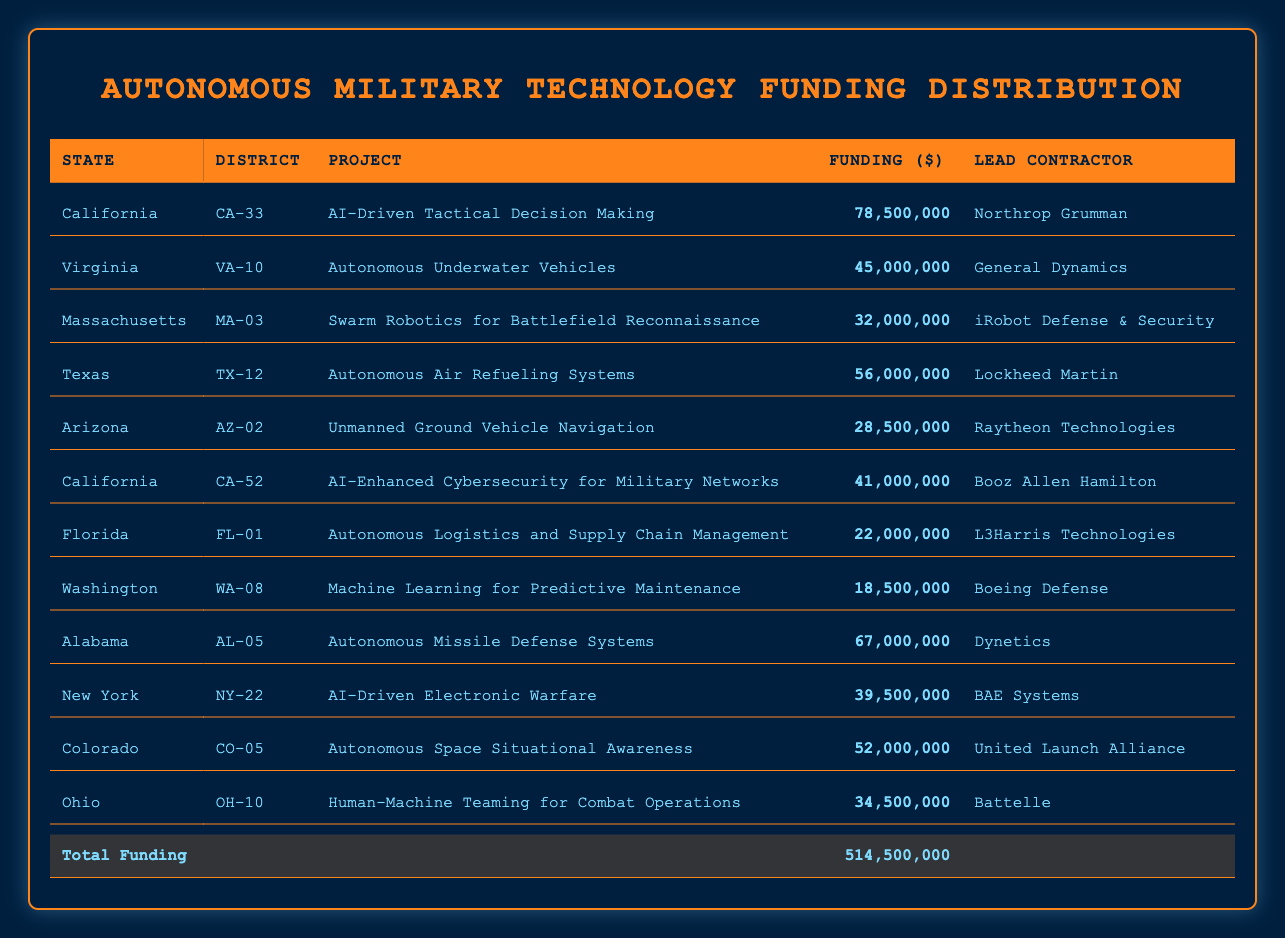What is the total funding amount for autonomous military projects in California? To find the total funding in California, I need to look at the funding values in the rows for California. The projects listed are: AI-Driven Tactical Decision Making ($78,500,000) and AI-Enhanced Cybersecurity for Military Networks ($41,000,000). Adding these gives a total of $78,500,000 + $41,000,000 = $119,500,000.
Answer: $119,500,000 Which state has the highest funding for autonomous military projects? I will check the funding amounts for each state and determine the highest value. Looking at the table, California has $119,500,000, and Alabama is next with $67,000,000, followed by Texas with $56,000,000. Therefore, California is the state with the highest funding amount.
Answer: California Was there any funding allocated to Florida for autonomous military projects? I check the Florida row to see if there are any funding details. The row indicates an allocation of $22,000,000 for the project Autonomous Logistics and Supply Chain Management. This confirms that funding was indeed allocated to Florida.
Answer: Yes What is the average funding amount for projects listed under Virginia and Texas? First, I locate the funding for Virginia and Texas. Virginia has $45,000,000 and Texas has $56,000,000. To calculate the average, I add these two amounts: $45,000,000 + $56,000,000 = $101,000,000. Then, I divide by 2 to find the average: $101,000,000 / 2 = $50,500,000.
Answer: $50,500,000 Does any project listed exceed $70 million in funding? I need to check all funding amounts for the projects in the table to see if any exceed $70 million. Reviewing the amounts, the highest is California's $78,500,000, which is more than $70 million, while others are lower. Thus, there is at least one project above $70 million.
Answer: Yes What is the total funding for projects led by Lockheed Martin and Raytheon Technologies? First, I identify the funding amounts for the respective contractors. Lockheed Martin's project (Autonomous Air Refueling Systems) has $56,000,000 and Raytheon Technologies (Unmanned Ground Vehicle Navigation) has $28,500,000. I will add these together: $56,000,000 + $28,500,000 = $84,500,000.
Answer: $84,500,000 Is there any funding for projects that involve AI? I review the projects to identify any involving AI. The projects "AI-Driven Tactical Decision Making" and "AI-Driven Electronic Warfare" both include AI and have funding amounts of $78,500,000 and $39,500,000 respectively. Therefore, funding for AI projects exists.
Answer: Yes How much funding was allocated to autonomous underwater vehicles in Virginia? By examining the Virginia row, it is clear that the project "Autonomous Underwater Vehicles" was funded with $45,000,000.
Answer: $45,000,000 What is the difference in funding between the lowest and highest funded projects? I will identify the highest and lowest funding amounts. The highest is California’s $78,500,000 and the lowest is Washington’s $18,500,000. To find the difference, I subtract: $78,500,000 - $18,500,000 = $60,000,000.
Answer: $60,000,000 